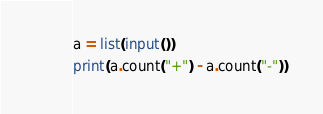<code> <loc_0><loc_0><loc_500><loc_500><_Python_>a = list(input())
print(a.count("+") - a.count("-"))</code> 